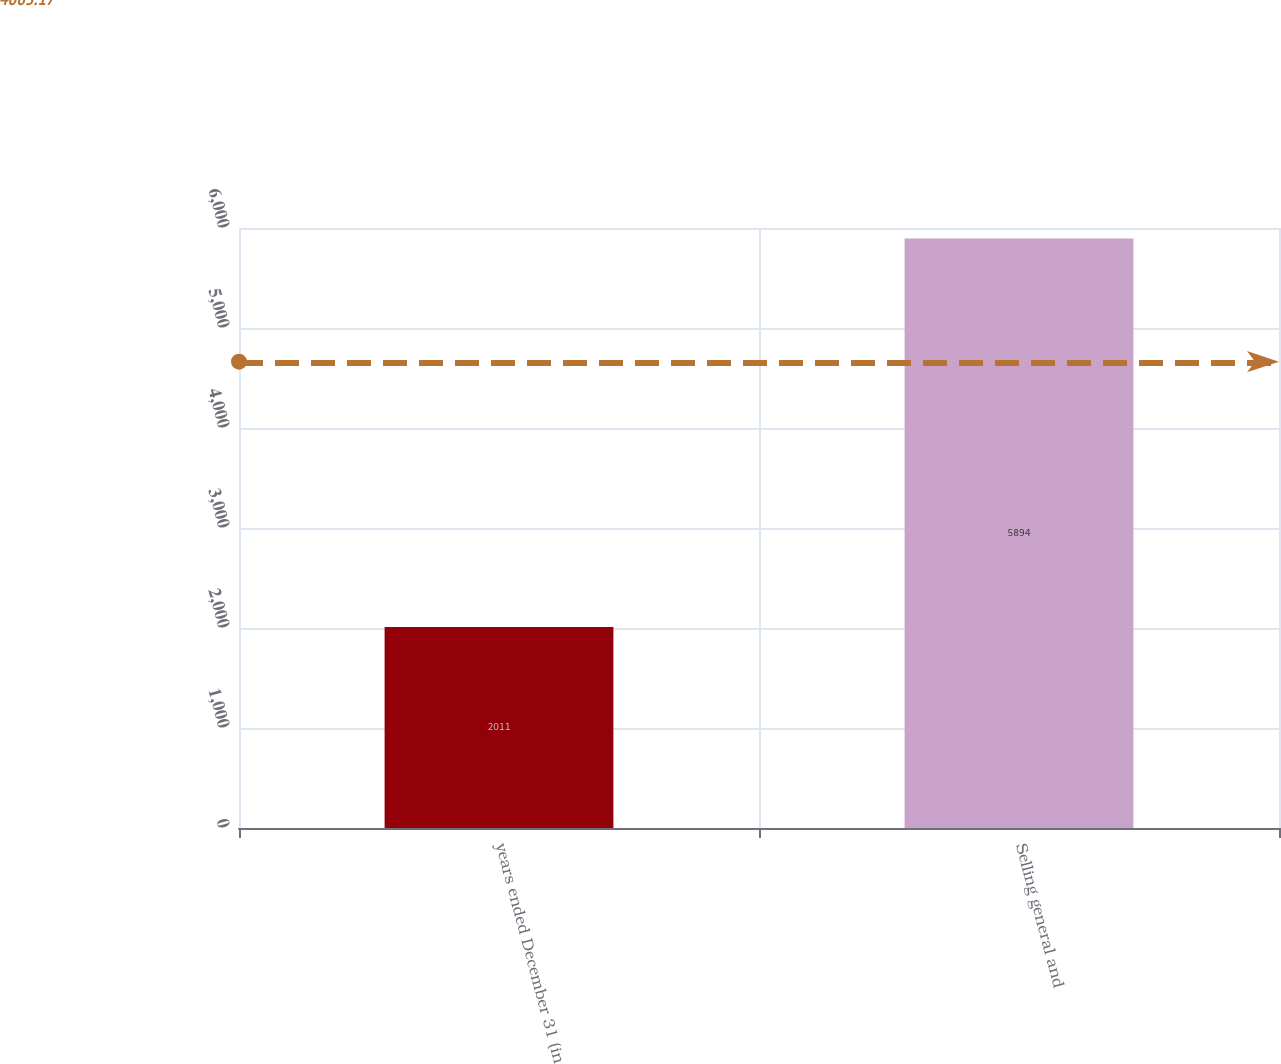<chart> <loc_0><loc_0><loc_500><loc_500><bar_chart><fcel>years ended December 31 (in<fcel>Selling general and<nl><fcel>2011<fcel>5894<nl></chart> 